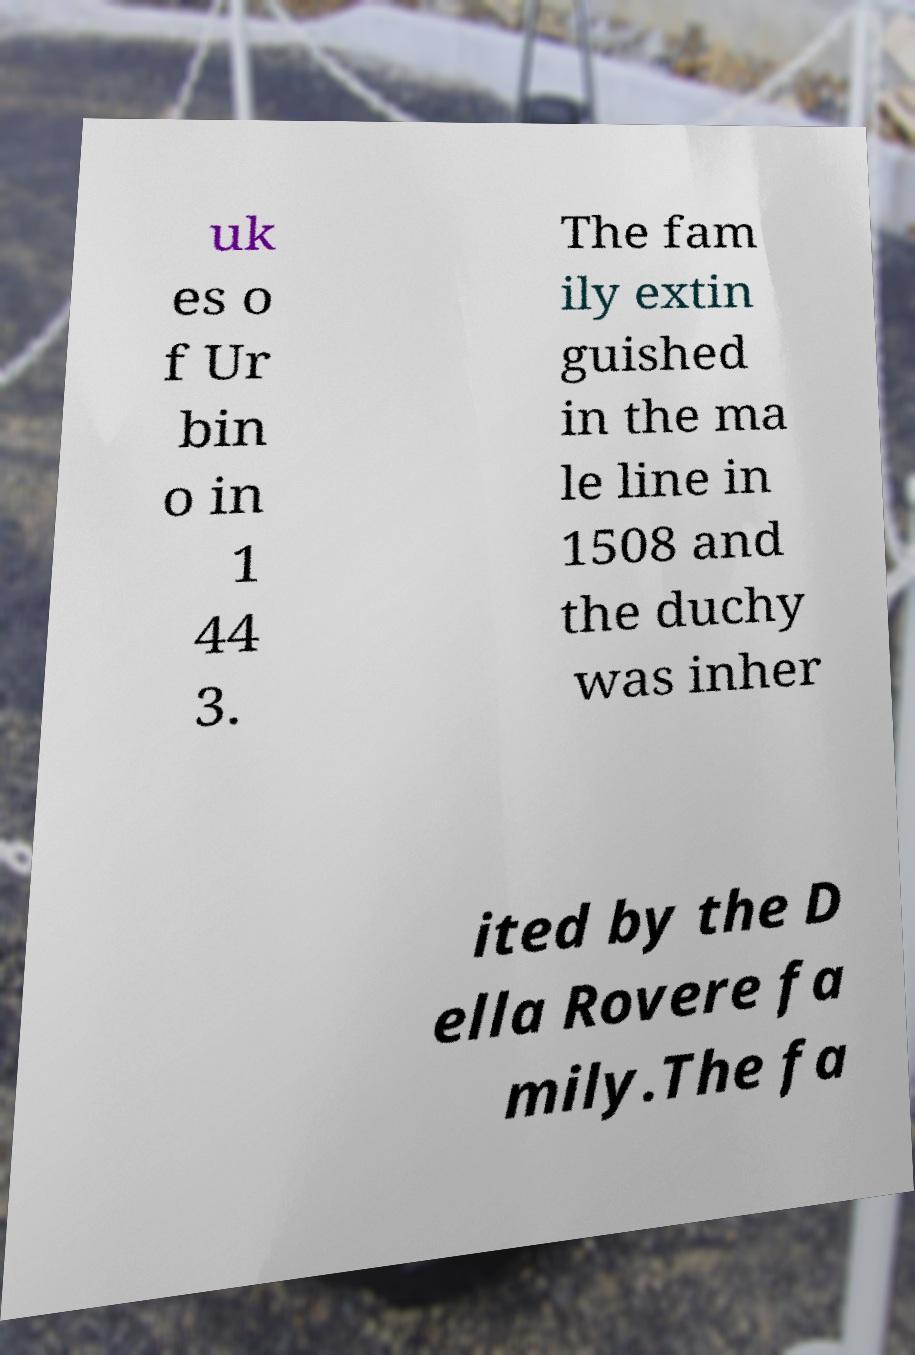What messages or text are displayed in this image? I need them in a readable, typed format. uk es o f Ur bin o in 1 44 3. The fam ily extin guished in the ma le line in 1508 and the duchy was inher ited by the D ella Rovere fa mily.The fa 